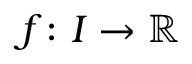<formula> <loc_0><loc_0><loc_500><loc_500>f \colon I \to \mathbb { R }</formula> 